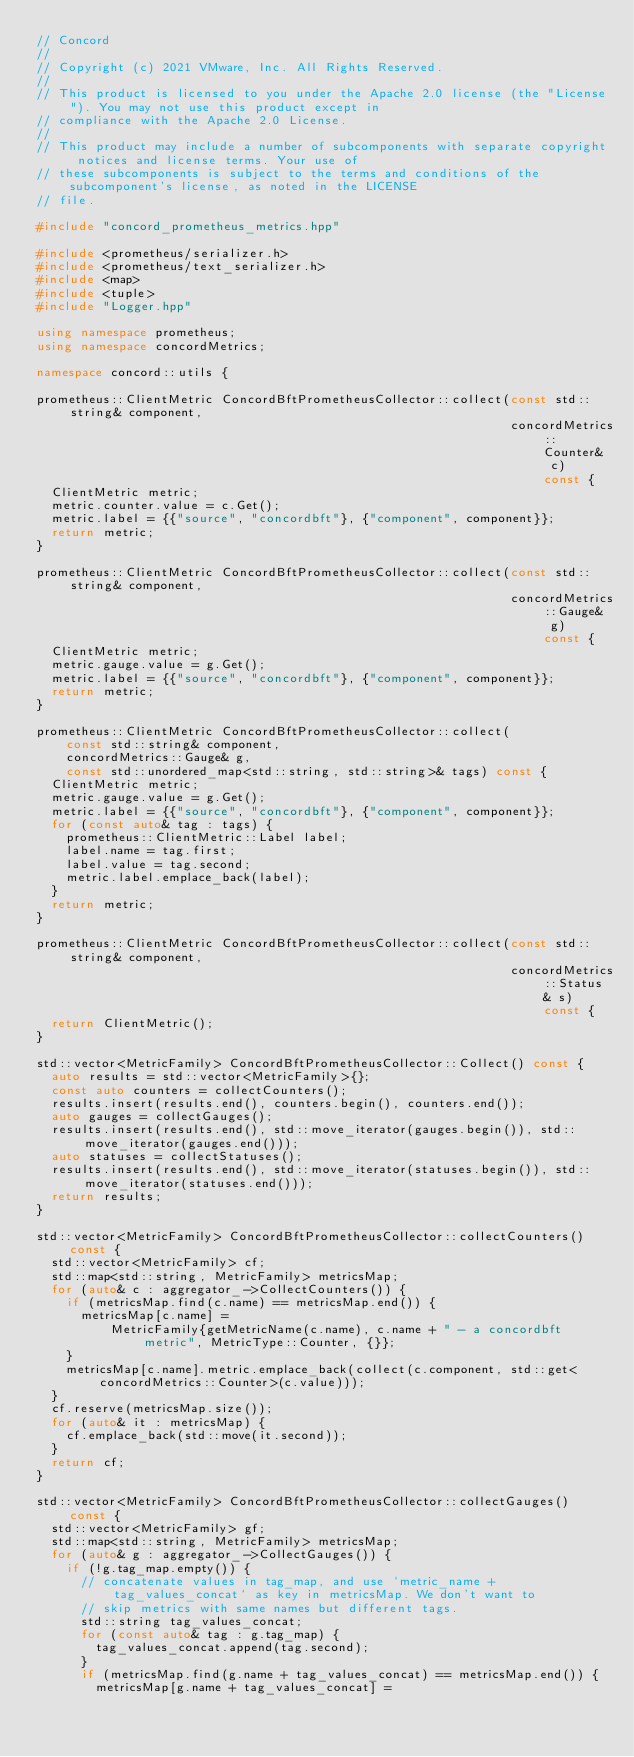Convert code to text. <code><loc_0><loc_0><loc_500><loc_500><_C++_>// Concord
//
// Copyright (c) 2021 VMware, Inc. All Rights Reserved.
//
// This product is licensed to you under the Apache 2.0 license (the "License"). You may not use this product except in
// compliance with the Apache 2.0 License.
//
// This product may include a number of subcomponents with separate copyright notices and license terms. Your use of
// these subcomponents is subject to the terms and conditions of the subcomponent's license, as noted in the LICENSE
// file.

#include "concord_prometheus_metrics.hpp"

#include <prometheus/serializer.h>
#include <prometheus/text_serializer.h>
#include <map>
#include <tuple>
#include "Logger.hpp"

using namespace prometheus;
using namespace concordMetrics;

namespace concord::utils {

prometheus::ClientMetric ConcordBftPrometheusCollector::collect(const std::string& component,
                                                                concordMetrics::Counter& c) const {
  ClientMetric metric;
  metric.counter.value = c.Get();
  metric.label = {{"source", "concordbft"}, {"component", component}};
  return metric;
}

prometheus::ClientMetric ConcordBftPrometheusCollector::collect(const std::string& component,
                                                                concordMetrics::Gauge& g) const {
  ClientMetric metric;
  metric.gauge.value = g.Get();
  metric.label = {{"source", "concordbft"}, {"component", component}};
  return metric;
}

prometheus::ClientMetric ConcordBftPrometheusCollector::collect(
    const std::string& component,
    concordMetrics::Gauge& g,
    const std::unordered_map<std::string, std::string>& tags) const {
  ClientMetric metric;
  metric.gauge.value = g.Get();
  metric.label = {{"source", "concordbft"}, {"component", component}};
  for (const auto& tag : tags) {
    prometheus::ClientMetric::Label label;
    label.name = tag.first;
    label.value = tag.second;
    metric.label.emplace_back(label);
  }
  return metric;
}

prometheus::ClientMetric ConcordBftPrometheusCollector::collect(const std::string& component,
                                                                concordMetrics::Status& s) const {
  return ClientMetric();
}

std::vector<MetricFamily> ConcordBftPrometheusCollector::Collect() const {
  auto results = std::vector<MetricFamily>{};
  const auto counters = collectCounters();
  results.insert(results.end(), counters.begin(), counters.end());
  auto gauges = collectGauges();
  results.insert(results.end(), std::move_iterator(gauges.begin()), std::move_iterator(gauges.end()));
  auto statuses = collectStatuses();
  results.insert(results.end(), std::move_iterator(statuses.begin()), std::move_iterator(statuses.end()));
  return results;
}

std::vector<MetricFamily> ConcordBftPrometheusCollector::collectCounters() const {
  std::vector<MetricFamily> cf;
  std::map<std::string, MetricFamily> metricsMap;
  for (auto& c : aggregator_->CollectCounters()) {
    if (metricsMap.find(c.name) == metricsMap.end()) {
      metricsMap[c.name] =
          MetricFamily{getMetricName(c.name), c.name + " - a concordbft metric", MetricType::Counter, {}};
    }
    metricsMap[c.name].metric.emplace_back(collect(c.component, std::get<concordMetrics::Counter>(c.value)));
  }
  cf.reserve(metricsMap.size());
  for (auto& it : metricsMap) {
    cf.emplace_back(std::move(it.second));
  }
  return cf;
}

std::vector<MetricFamily> ConcordBftPrometheusCollector::collectGauges() const {
  std::vector<MetricFamily> gf;
  std::map<std::string, MetricFamily> metricsMap;
  for (auto& g : aggregator_->CollectGauges()) {
    if (!g.tag_map.empty()) {
      // concatenate values in tag_map, and use `metric_name + tag_values_concat` as key in metricsMap. We don't want to
      // skip metrics with same names but different tags.
      std::string tag_values_concat;
      for (const auto& tag : g.tag_map) {
        tag_values_concat.append(tag.second);
      }
      if (metricsMap.find(g.name + tag_values_concat) == metricsMap.end()) {
        metricsMap[g.name + tag_values_concat] =</code> 